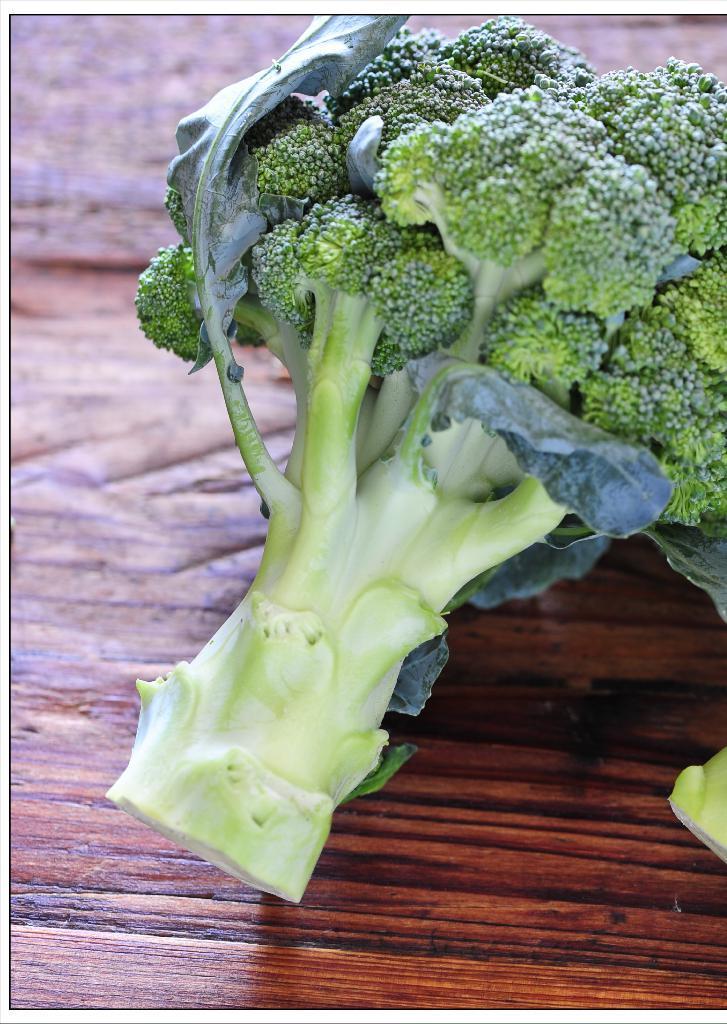Describe this image in one or two sentences. In this image we can see a broccoli on the wooden surface. 